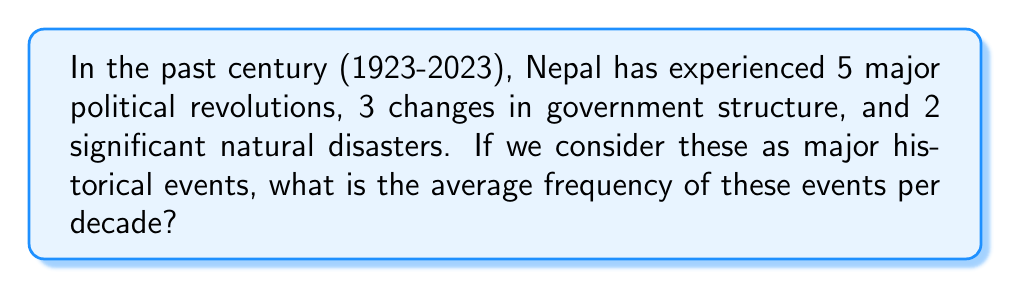Show me your answer to this math problem. To solve this problem, let's follow these steps:

1. Calculate the total number of major historical events:
   $$5 + 3 + 2 = 10$$ major events

2. Determine the number of decades in a century:
   $$100 \text{ years} \div 10 \text{ years per decade} = 10 \text{ decades}$$

3. Calculate the average frequency of events per decade:
   $$\text{Average frequency} = \frac{\text{Total number of events}}{\text{Number of decades}}$$
   
   $$\text{Average frequency} = \frac{10 \text{ events}}{10 \text{ decades}}$$
   
   $$\text{Average frequency} = 1 \text{ event per decade}$$

Therefore, on average, there has been 1 major historical event per decade in Nepal over the past century.
Answer: 1 event per decade 